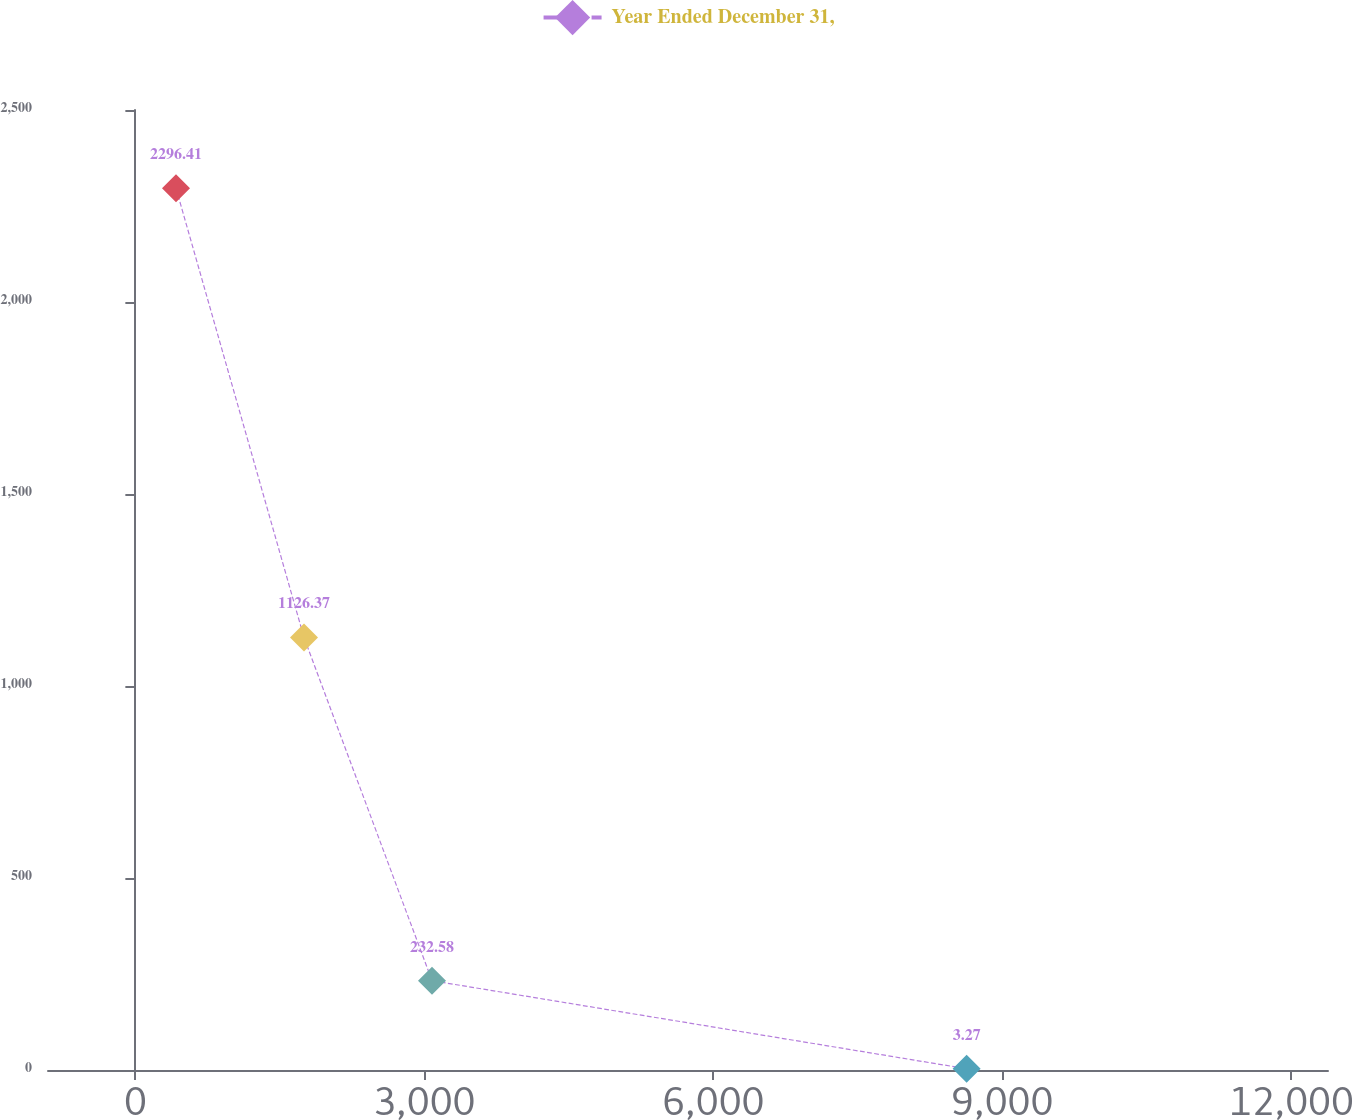Convert chart to OTSL. <chart><loc_0><loc_0><loc_500><loc_500><line_chart><ecel><fcel>Year Ended December 31,<nl><fcel>421.87<fcel>2296.41<nl><fcel>1750.65<fcel>1126.37<nl><fcel>3079.43<fcel>232.58<nl><fcel>8629.59<fcel>3.27<nl><fcel>13709.7<fcel>737.58<nl></chart> 